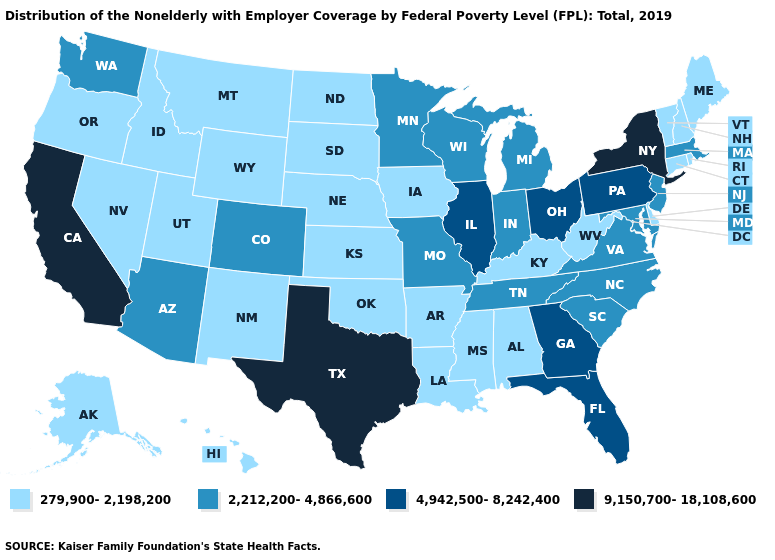What is the lowest value in the South?
Quick response, please. 279,900-2,198,200. What is the value of Oklahoma?
Give a very brief answer. 279,900-2,198,200. What is the value of Delaware?
Be succinct. 279,900-2,198,200. Does Arizona have the lowest value in the West?
Write a very short answer. No. Which states have the highest value in the USA?
Give a very brief answer. California, New York, Texas. Does Alabama have the highest value in the South?
Be succinct. No. What is the lowest value in the South?
Answer briefly. 279,900-2,198,200. Name the states that have a value in the range 9,150,700-18,108,600?
Quick response, please. California, New York, Texas. Does Georgia have the lowest value in the USA?
Short answer required. No. Does Illinois have the lowest value in the MidWest?
Answer briefly. No. What is the value of Washington?
Be succinct. 2,212,200-4,866,600. Among the states that border Alabama , which have the lowest value?
Concise answer only. Mississippi. What is the highest value in states that border Michigan?
Quick response, please. 4,942,500-8,242,400. What is the highest value in states that border Nebraska?
Short answer required. 2,212,200-4,866,600. Name the states that have a value in the range 4,942,500-8,242,400?
Keep it brief. Florida, Georgia, Illinois, Ohio, Pennsylvania. 